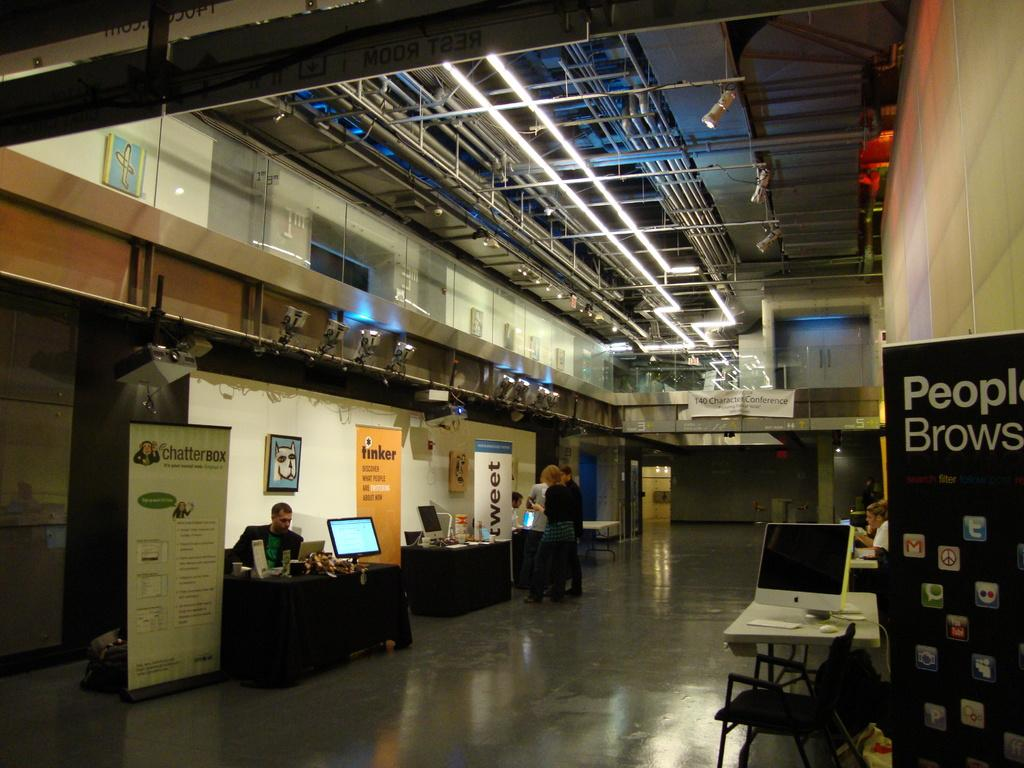How many people are in the image? There are people in the image, but the exact number is not specified. What are the people in the image doing? Some people are sitting, while others are standing. What objects are on the tables in the image? There are monitors on the tables. What type of pets can be seen playing with the people in the image? There are no pets present in the image; it only features people and tables with monitors. 